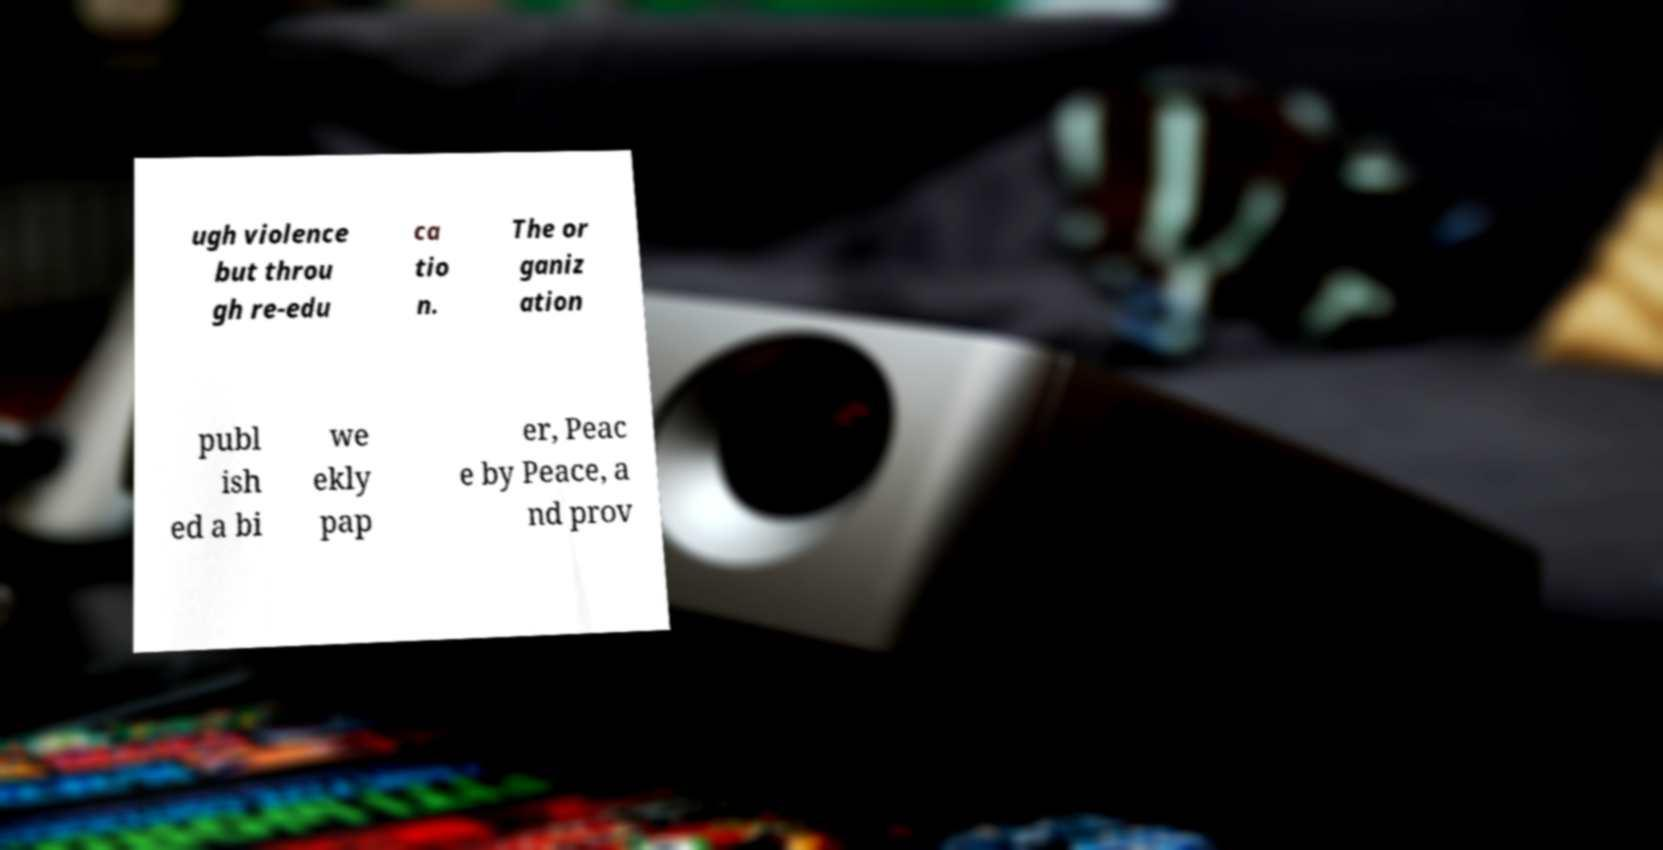Could you extract and type out the text from this image? ugh violence but throu gh re-edu ca tio n. The or ganiz ation publ ish ed a bi we ekly pap er, Peac e by Peace, a nd prov 